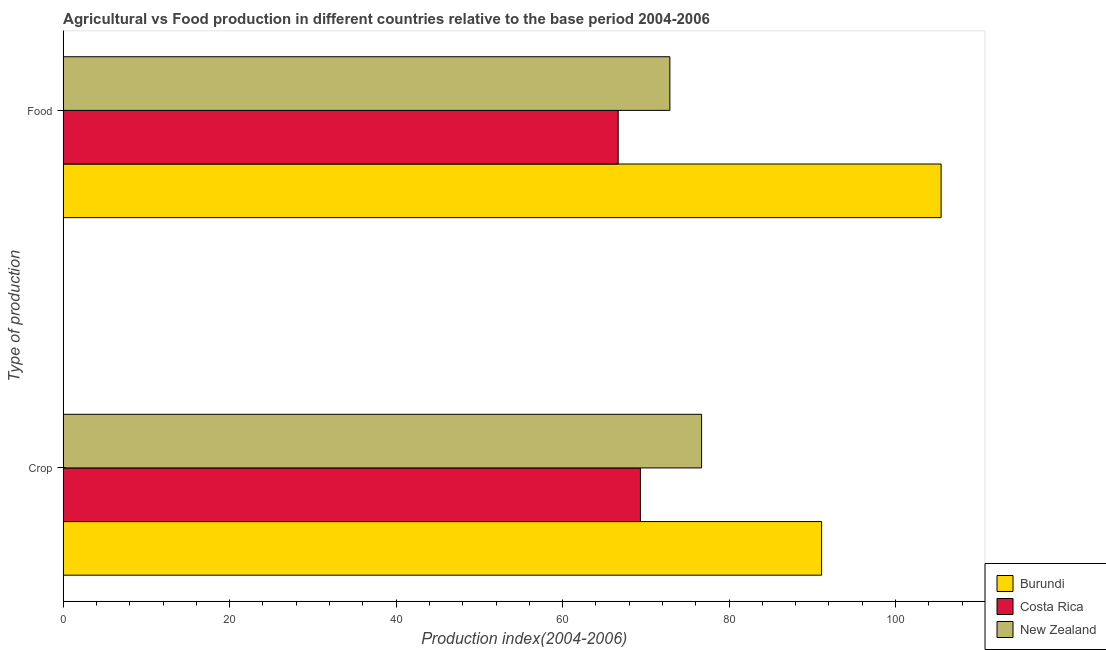How many different coloured bars are there?
Give a very brief answer. 3. How many groups of bars are there?
Your response must be concise. 2. How many bars are there on the 2nd tick from the top?
Offer a very short reply. 3. What is the label of the 1st group of bars from the top?
Provide a short and direct response. Food. What is the food production index in Burundi?
Ensure brevity in your answer.  105.48. Across all countries, what is the maximum food production index?
Your answer should be compact. 105.48. Across all countries, what is the minimum crop production index?
Provide a short and direct response. 69.35. In which country was the crop production index maximum?
Your answer should be very brief. Burundi. In which country was the food production index minimum?
Ensure brevity in your answer.  Costa Rica. What is the total crop production index in the graph?
Your answer should be very brief. 237.17. What is the difference between the food production index in New Zealand and that in Burundi?
Keep it short and to the point. -32.59. What is the difference between the food production index in Costa Rica and the crop production index in New Zealand?
Your answer should be very brief. -10.02. What is the average crop production index per country?
Your answer should be compact. 79.06. What is the difference between the food production index and crop production index in New Zealand?
Your answer should be very brief. -3.81. In how many countries, is the food production index greater than 72 ?
Ensure brevity in your answer.  2. What is the ratio of the crop production index in Burundi to that in New Zealand?
Offer a terse response. 1.19. Is the food production index in Costa Rica less than that in Burundi?
Give a very brief answer. Yes. What does the 1st bar from the top in Crop represents?
Provide a short and direct response. New Zealand. What does the 3rd bar from the bottom in Food represents?
Give a very brief answer. New Zealand. Are all the bars in the graph horizontal?
Keep it short and to the point. Yes. Are the values on the major ticks of X-axis written in scientific E-notation?
Ensure brevity in your answer.  No. How many legend labels are there?
Give a very brief answer. 3. How are the legend labels stacked?
Give a very brief answer. Vertical. What is the title of the graph?
Give a very brief answer. Agricultural vs Food production in different countries relative to the base period 2004-2006. What is the label or title of the X-axis?
Your answer should be compact. Production index(2004-2006). What is the label or title of the Y-axis?
Keep it short and to the point. Type of production. What is the Production index(2004-2006) in Burundi in Crop?
Keep it short and to the point. 91.12. What is the Production index(2004-2006) in Costa Rica in Crop?
Your answer should be very brief. 69.35. What is the Production index(2004-2006) of New Zealand in Crop?
Provide a short and direct response. 76.7. What is the Production index(2004-2006) of Burundi in Food?
Give a very brief answer. 105.48. What is the Production index(2004-2006) in Costa Rica in Food?
Ensure brevity in your answer.  66.68. What is the Production index(2004-2006) of New Zealand in Food?
Your answer should be very brief. 72.89. Across all Type of production, what is the maximum Production index(2004-2006) in Burundi?
Your response must be concise. 105.48. Across all Type of production, what is the maximum Production index(2004-2006) in Costa Rica?
Offer a terse response. 69.35. Across all Type of production, what is the maximum Production index(2004-2006) of New Zealand?
Give a very brief answer. 76.7. Across all Type of production, what is the minimum Production index(2004-2006) in Burundi?
Provide a succinct answer. 91.12. Across all Type of production, what is the minimum Production index(2004-2006) in Costa Rica?
Offer a terse response. 66.68. Across all Type of production, what is the minimum Production index(2004-2006) in New Zealand?
Your response must be concise. 72.89. What is the total Production index(2004-2006) in Burundi in the graph?
Provide a succinct answer. 196.6. What is the total Production index(2004-2006) in Costa Rica in the graph?
Ensure brevity in your answer.  136.03. What is the total Production index(2004-2006) of New Zealand in the graph?
Offer a terse response. 149.59. What is the difference between the Production index(2004-2006) in Burundi in Crop and that in Food?
Provide a succinct answer. -14.36. What is the difference between the Production index(2004-2006) in Costa Rica in Crop and that in Food?
Your answer should be compact. 2.67. What is the difference between the Production index(2004-2006) in New Zealand in Crop and that in Food?
Provide a succinct answer. 3.81. What is the difference between the Production index(2004-2006) in Burundi in Crop and the Production index(2004-2006) in Costa Rica in Food?
Offer a terse response. 24.44. What is the difference between the Production index(2004-2006) in Burundi in Crop and the Production index(2004-2006) in New Zealand in Food?
Ensure brevity in your answer.  18.23. What is the difference between the Production index(2004-2006) of Costa Rica in Crop and the Production index(2004-2006) of New Zealand in Food?
Your answer should be very brief. -3.54. What is the average Production index(2004-2006) in Burundi per Type of production?
Ensure brevity in your answer.  98.3. What is the average Production index(2004-2006) of Costa Rica per Type of production?
Your answer should be compact. 68.02. What is the average Production index(2004-2006) of New Zealand per Type of production?
Keep it short and to the point. 74.8. What is the difference between the Production index(2004-2006) in Burundi and Production index(2004-2006) in Costa Rica in Crop?
Provide a short and direct response. 21.77. What is the difference between the Production index(2004-2006) of Burundi and Production index(2004-2006) of New Zealand in Crop?
Your answer should be very brief. 14.42. What is the difference between the Production index(2004-2006) of Costa Rica and Production index(2004-2006) of New Zealand in Crop?
Give a very brief answer. -7.35. What is the difference between the Production index(2004-2006) in Burundi and Production index(2004-2006) in Costa Rica in Food?
Your answer should be compact. 38.8. What is the difference between the Production index(2004-2006) of Burundi and Production index(2004-2006) of New Zealand in Food?
Your response must be concise. 32.59. What is the difference between the Production index(2004-2006) in Costa Rica and Production index(2004-2006) in New Zealand in Food?
Make the answer very short. -6.21. What is the ratio of the Production index(2004-2006) of Burundi in Crop to that in Food?
Give a very brief answer. 0.86. What is the ratio of the Production index(2004-2006) in New Zealand in Crop to that in Food?
Offer a terse response. 1.05. What is the difference between the highest and the second highest Production index(2004-2006) in Burundi?
Your answer should be compact. 14.36. What is the difference between the highest and the second highest Production index(2004-2006) in Costa Rica?
Offer a very short reply. 2.67. What is the difference between the highest and the second highest Production index(2004-2006) in New Zealand?
Keep it short and to the point. 3.81. What is the difference between the highest and the lowest Production index(2004-2006) in Burundi?
Your response must be concise. 14.36. What is the difference between the highest and the lowest Production index(2004-2006) of Costa Rica?
Ensure brevity in your answer.  2.67. What is the difference between the highest and the lowest Production index(2004-2006) in New Zealand?
Offer a very short reply. 3.81. 